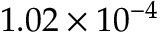Convert formula to latex. <formula><loc_0><loc_0><loc_500><loc_500>1 . 0 2 \times 1 0 ^ { - 4 }</formula> 